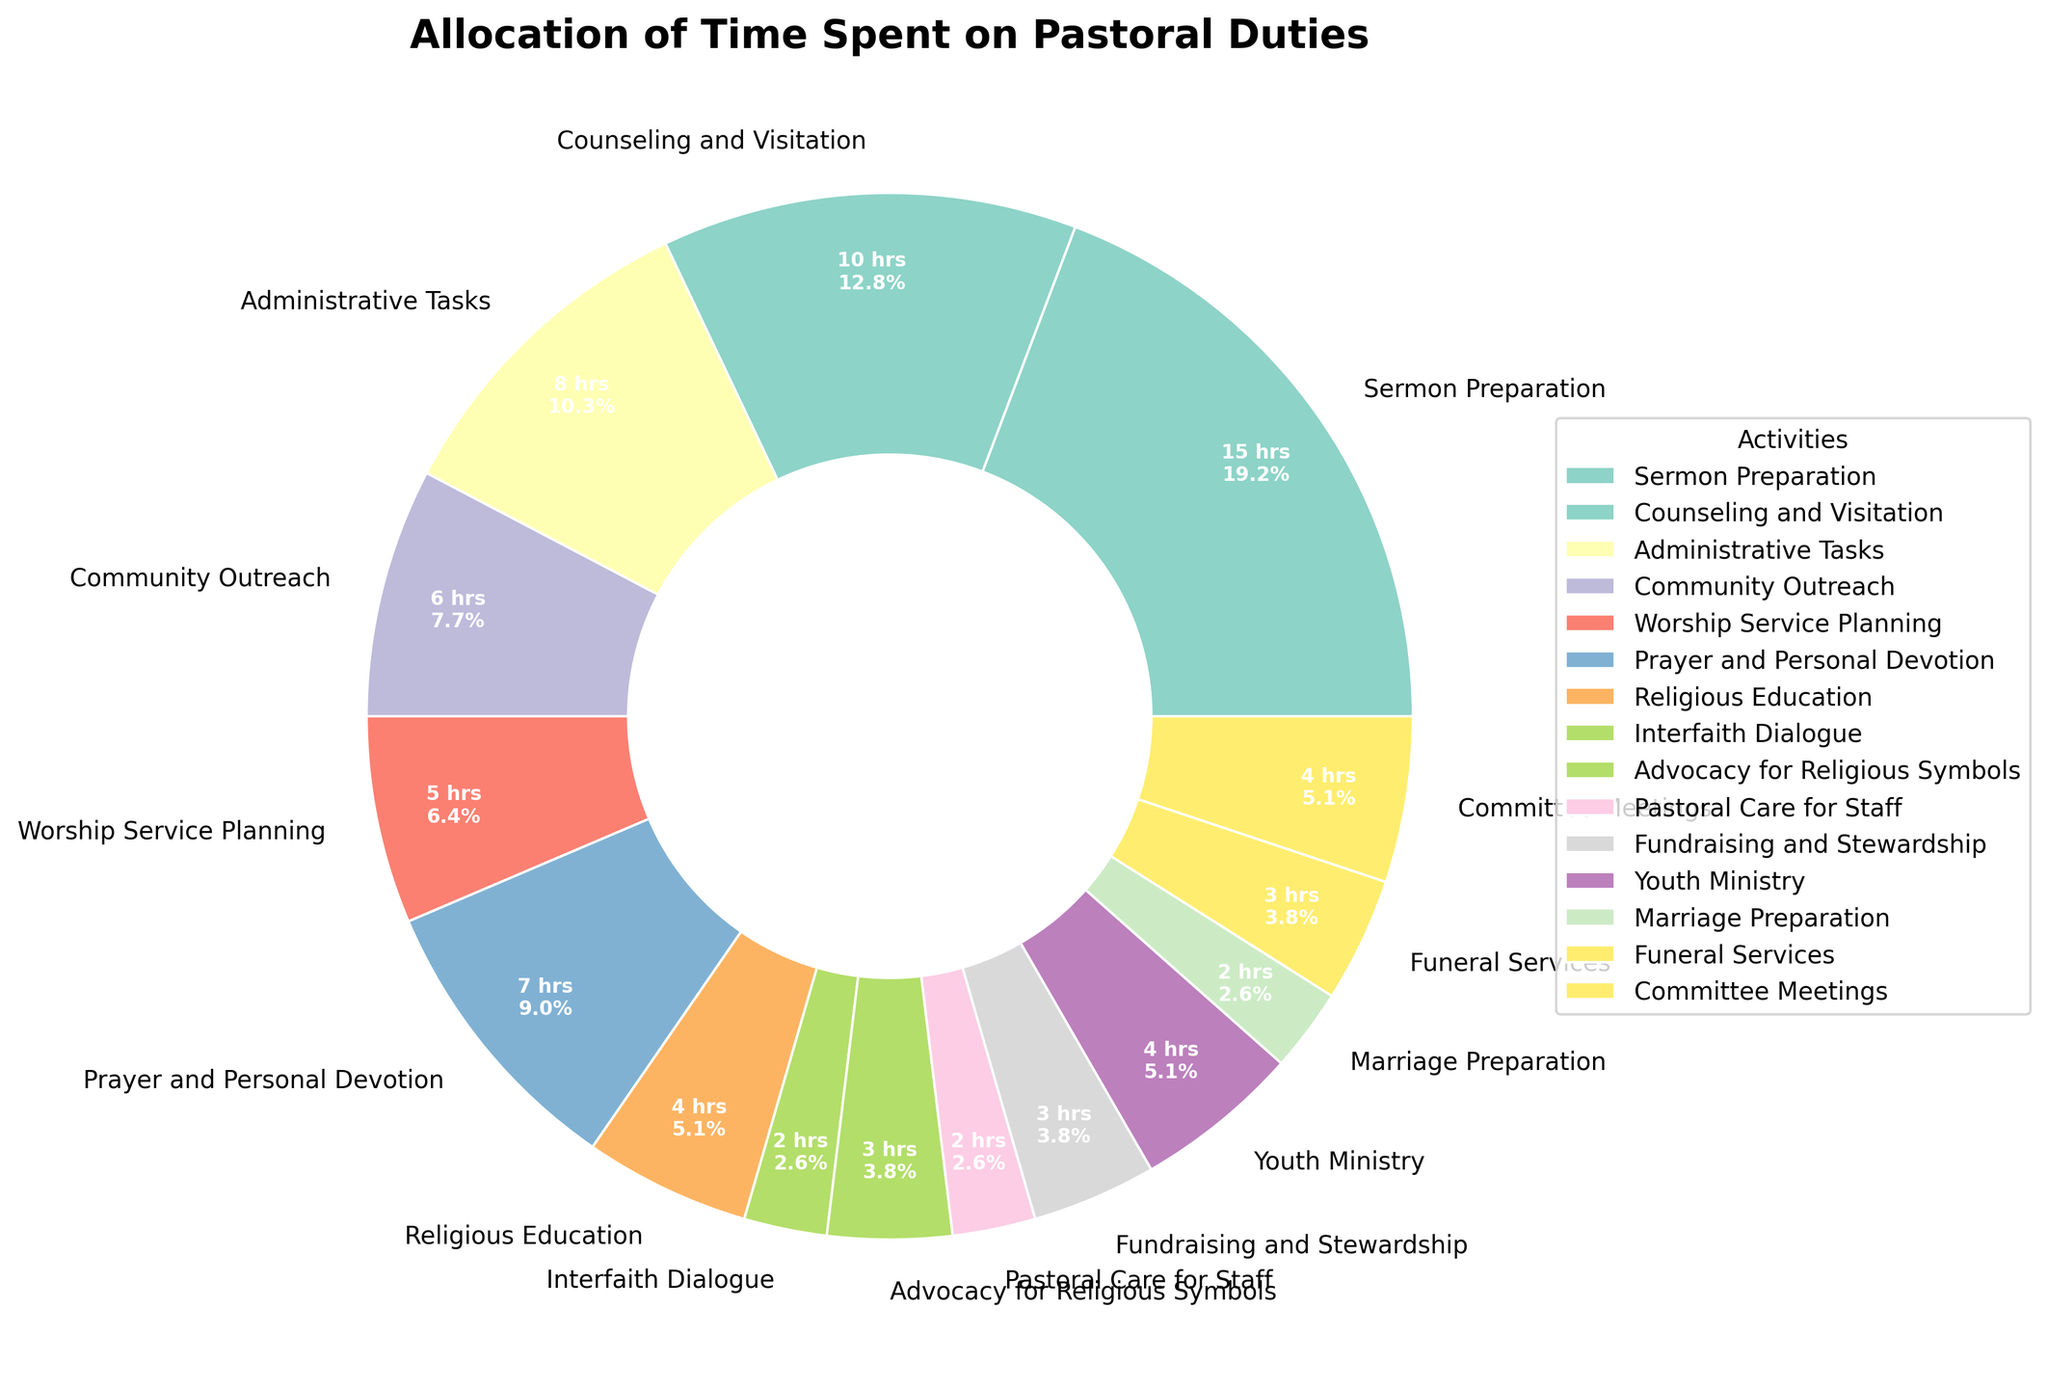Which activity takes up the most hours per week? The activity with the largest percentage on the pie chart is the one that takes up the most hours. Here, "Sermon Preparation" occupies the largest slice.
Answer: Sermon Preparation Which activity takes up the least hours per week? The activity with the smallest percentage on the pie chart is the one that takes the least hours. Here, "Interfaith Dialogue" and "Pastoral Care for Staff" both have small slices.
Answer: Interfaith Dialogue and Pastoral Care for Staff How many hours per week are spent on "Counseling and Visitation" and "Administrative Tasks" combined? Add the hours for "Counseling and Visitation" (10 hours) and "Administrative Tasks" (8 hours).
Answer: 18 hours Which two activities have equal time allocation? Look for activities with the same percentage slice on the chart. "Marriage Preparation" and "Pastoral Care for Staff" both take 2 hours per week.
Answer: Marriage Preparation and Pastoral Care for Staff How much more time is spent on "Sermon Preparation" compared to "Funeral Services"? Subtract the hours spent on "Funeral Services" (3 hours) from the hours spent on "Sermon Preparation" (15 hours).
Answer: 12 hours What percentage of the total time is spent on "Advocacy for Religious Symbols"? The pie chart gives percentages for each slice. The percentage for "Advocacy for Religious Symbols" should be part of the labels next to each slice.
Answer: 3.7% How does the time spent on "Youth Ministry" compare to "Community Outreach"? Compare the hours for "Youth Ministry" (4 hours) with "Community Outreach" (6 hours). "Youth Ministry" takes less time than "Community Outreach".
Answer: Youth Ministry takes less time Which activities are allocated 4 hours per week? Look for slices that represent 4 hours on the pie chart. "Religious Education," "Youth Ministry," and "Committee Meetings" each take 4 hours per week.
Answer: Religious Education, Youth Ministry, Committee Meetings What is the total time allocated to the top three activities with the most hours? Identify the top three activities by hours: "Sermon Preparation" (15 hours), "Counseling and Visitation" (10 hours), and "Administrative Tasks" (8 hours). Add these together.
Answer: 33 hours 